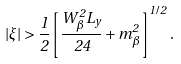Convert formula to latex. <formula><loc_0><loc_0><loc_500><loc_500>| \xi | > \frac { 1 } { 2 } \left [ \frac { W _ { \beta } ^ { 2 } L _ { y } } { 2 4 } + m _ { \beta } ^ { 2 } \right ] ^ { 1 / 2 } .</formula> 